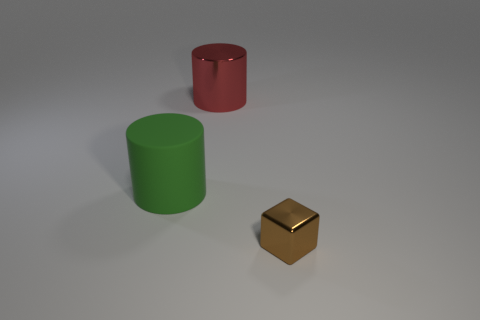Add 3 green metal cubes. How many objects exist? 6 Subtract all red cylinders. How many cylinders are left? 1 Subtract 0 yellow cylinders. How many objects are left? 3 Subtract all cylinders. How many objects are left? 1 Subtract all blue cylinders. Subtract all purple balls. How many cylinders are left? 2 Subtract all cyan cubes. How many green cylinders are left? 1 Subtract all rubber things. Subtract all big green objects. How many objects are left? 1 Add 3 brown metal blocks. How many brown metal blocks are left? 4 Add 1 big green things. How many big green things exist? 2 